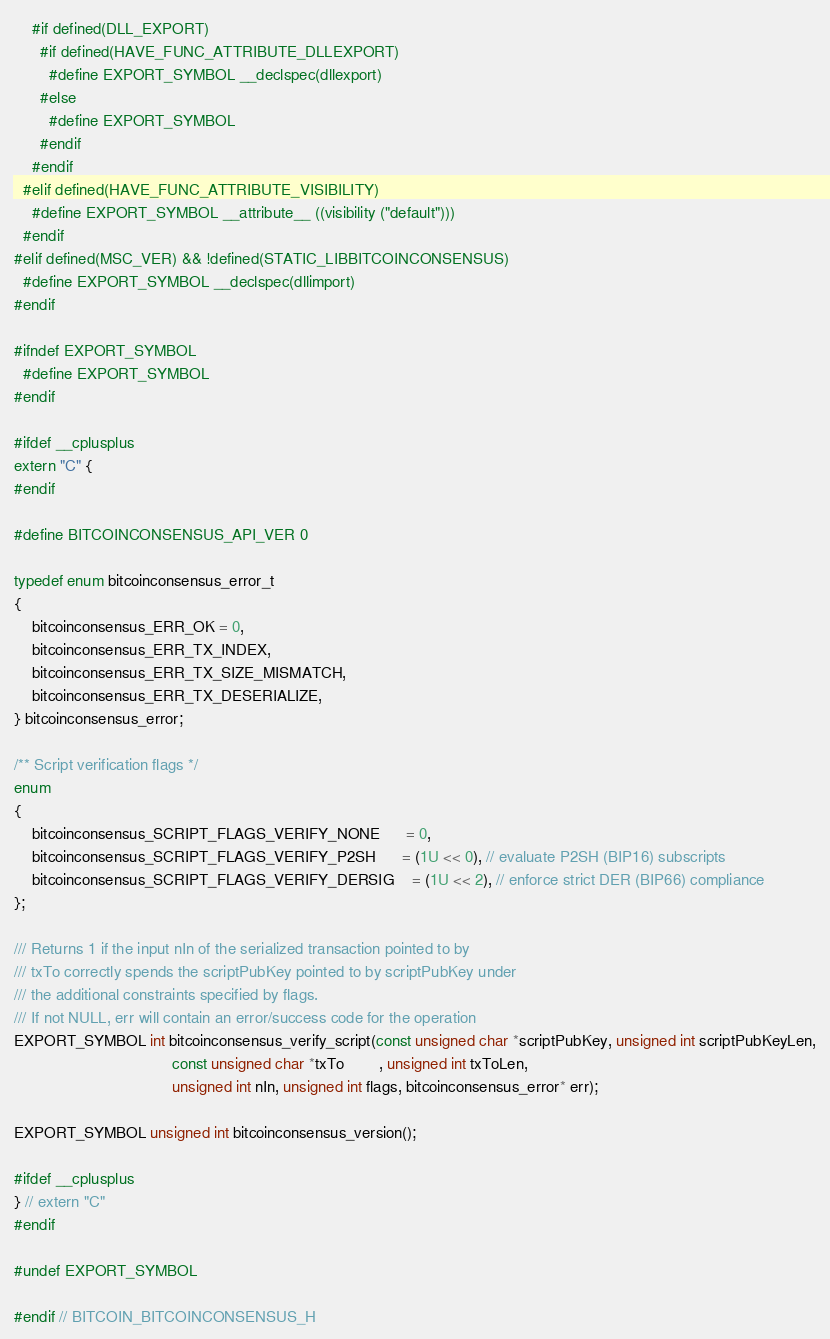<code> <loc_0><loc_0><loc_500><loc_500><_C_>    #if defined(DLL_EXPORT)
      #if defined(HAVE_FUNC_ATTRIBUTE_DLLEXPORT)
        #define EXPORT_SYMBOL __declspec(dllexport)
      #else
        #define EXPORT_SYMBOL
      #endif
    #endif
  #elif defined(HAVE_FUNC_ATTRIBUTE_VISIBILITY)
    #define EXPORT_SYMBOL __attribute__ ((visibility ("default")))
  #endif
#elif defined(MSC_VER) && !defined(STATIC_LIBBITCOINCONSENSUS)
  #define EXPORT_SYMBOL __declspec(dllimport)
#endif

#ifndef EXPORT_SYMBOL
  #define EXPORT_SYMBOL
#endif

#ifdef __cplusplus
extern "C" {
#endif

#define BITCOINCONSENSUS_API_VER 0

typedef enum bitcoinconsensus_error_t
{
    bitcoinconsensus_ERR_OK = 0,
    bitcoinconsensus_ERR_TX_INDEX,
    bitcoinconsensus_ERR_TX_SIZE_MISMATCH,
    bitcoinconsensus_ERR_TX_DESERIALIZE,
} bitcoinconsensus_error;

/** Script verification flags */
enum
{
    bitcoinconsensus_SCRIPT_FLAGS_VERIFY_NONE      = 0,
    bitcoinconsensus_SCRIPT_FLAGS_VERIFY_P2SH      = (1U << 0), // evaluate P2SH (BIP16) subscripts
    bitcoinconsensus_SCRIPT_FLAGS_VERIFY_DERSIG    = (1U << 2), // enforce strict DER (BIP66) compliance
};

/// Returns 1 if the input nIn of the serialized transaction pointed to by
/// txTo correctly spends the scriptPubKey pointed to by scriptPubKey under
/// the additional constraints specified by flags.
/// If not NULL, err will contain an error/success code for the operation
EXPORT_SYMBOL int bitcoinconsensus_verify_script(const unsigned char *scriptPubKey, unsigned int scriptPubKeyLen,
                                    const unsigned char *txTo        , unsigned int txToLen,
                                    unsigned int nIn, unsigned int flags, bitcoinconsensus_error* err);

EXPORT_SYMBOL unsigned int bitcoinconsensus_version();

#ifdef __cplusplus
} // extern "C"
#endif

#undef EXPORT_SYMBOL

#endif // BITCOIN_BITCOINCONSENSUS_H
</code> 